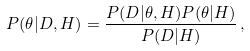<formula> <loc_0><loc_0><loc_500><loc_500>P ( \theta | D , H ) = \frac { P ( D | \theta , H ) P ( \theta | H ) } { P ( D | H ) } \, ,</formula> 